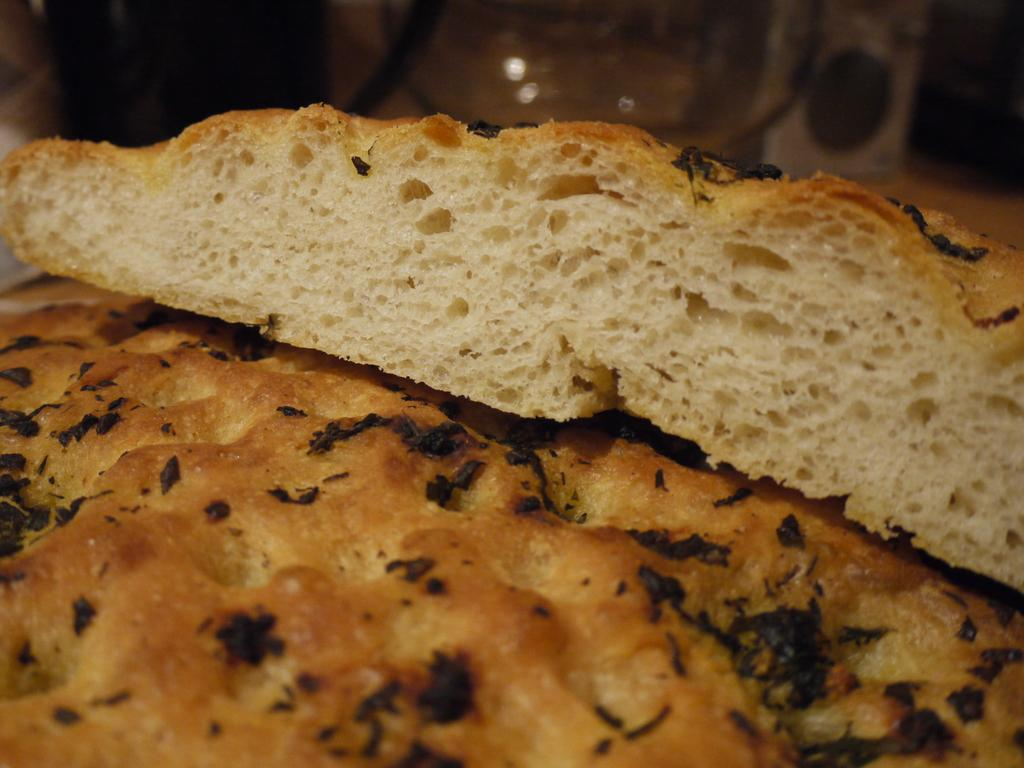What type of food item can be seen in the image? There is a food item in the image that looks like bread. Can you describe the background of the image? The background image is blurred. What type of bell can be seen ringing in the background of the image? There is no bell present in the image; the background is blurred. What holiday is being celebrated in the image? There is no indication of a holiday being celebrated in the image. 